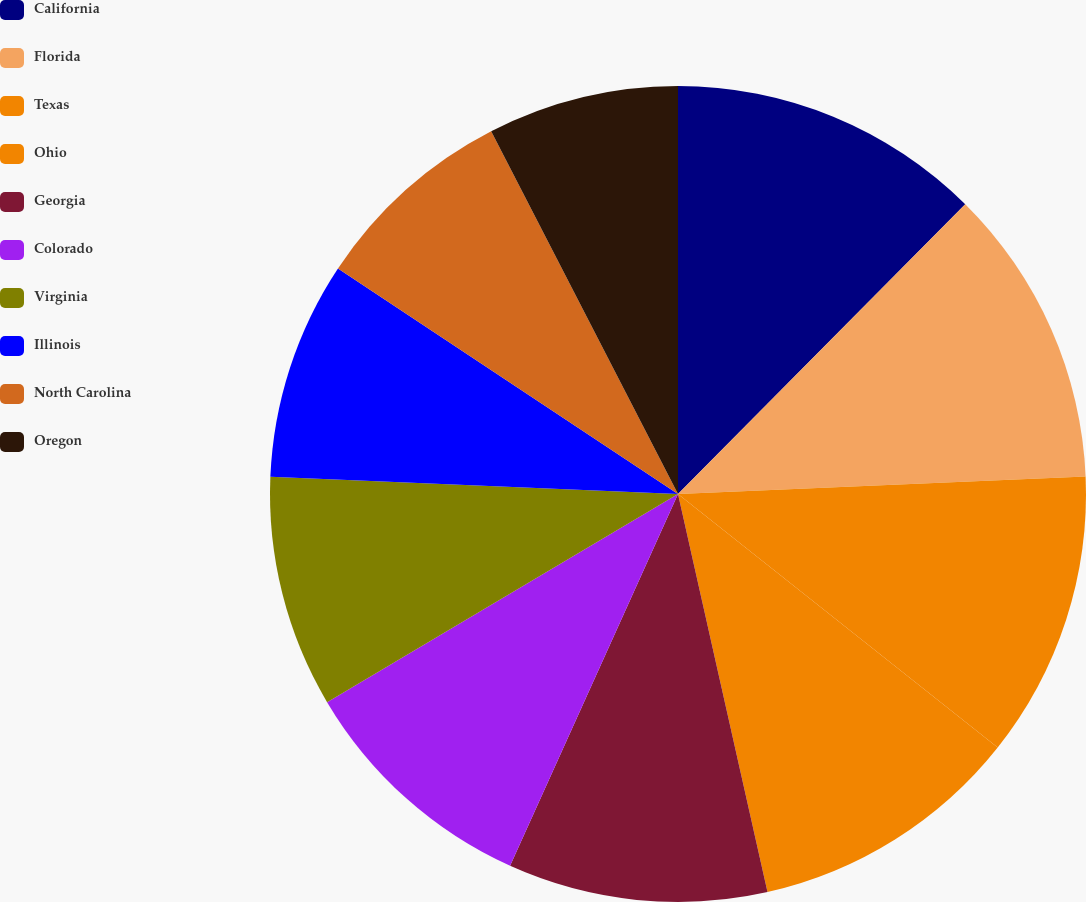Convert chart. <chart><loc_0><loc_0><loc_500><loc_500><pie_chart><fcel>California<fcel>Florida<fcel>Texas<fcel>Ohio<fcel>Georgia<fcel>Colorado<fcel>Virginia<fcel>Illinois<fcel>North Carolina<fcel>Oregon<nl><fcel>12.43%<fcel>11.89%<fcel>11.35%<fcel>10.81%<fcel>10.27%<fcel>9.73%<fcel>9.19%<fcel>8.65%<fcel>8.11%<fcel>7.57%<nl></chart> 